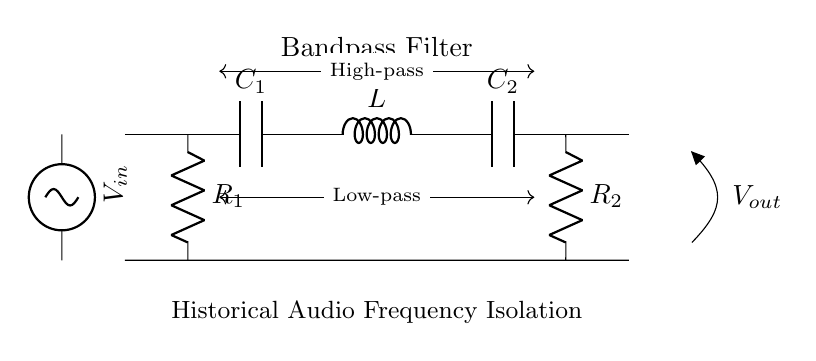What type of filter is represented in this circuit? The circuit diagram indicates a bandpass filter, as shown by the specific arrangement of components that allows a certain range of frequencies to pass while attenuating others.
Answer: Bandpass filter What components are used in this filter circuit? The circuit includes capacitors (C1, C2), an inductor (L), and resistors (R1, R2), as labeled in the diagram, which are essential for filtering specific frequencies.
Answer: Capacitors, inductor, resistors Where does the input voltage connect to the circuit? The input voltage, denoted as V_in, is connected to the leftmost side of the circuit diagram, feeding into the first capacitor (C1).
Answer: Left side What is the purpose of R1 and R2 in this circuit? R1 and R2 serve as load resistors that can help in defining the cutoff frequencies of the filter and influence the circuit's behavior with respect to voltage and current.
Answer: Load resistors What is indicated by the arrows labeled "Low-pass" and "High-pass"? The arrows represent the frequency response characteristics of the bandpass filter, indicating that it allows frequencies within a certain range (between low and high cutoff frequencies) to pass while rejecting others.
Answer: Frequency response characteristics How does the arrangement of components define this circuit as a bandpass filter? The combination of a capacitor in series with an inductor and a capacitor in parallel with an output resistor forms a bandpass configuration, allowing only a certain range of frequencies to be transmitted, due to the reactive properties of the components.
Answer: Reactive properties of components 